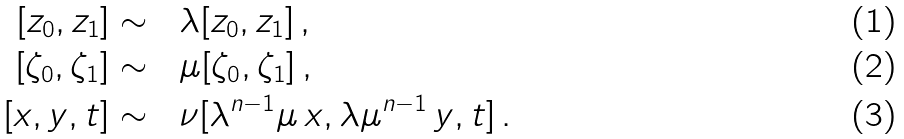Convert formula to latex. <formula><loc_0><loc_0><loc_500><loc_500>\left [ z _ { 0 } , z _ { 1 } \right ] \sim & \quad \lambda [ z _ { 0 } , z _ { 1 } ] \, , \\ \left [ \zeta _ { 0 } , \zeta _ { 1 } \right ] \sim & \quad \mu [ \zeta _ { 0 } , \zeta _ { 1 } ] \, , \\ \left [ x , y , t \right ] \sim & \quad \nu [ \lambda ^ { n - 1 } \mu \, x , \lambda \mu ^ { n - 1 } \, y , t ] \, .</formula> 